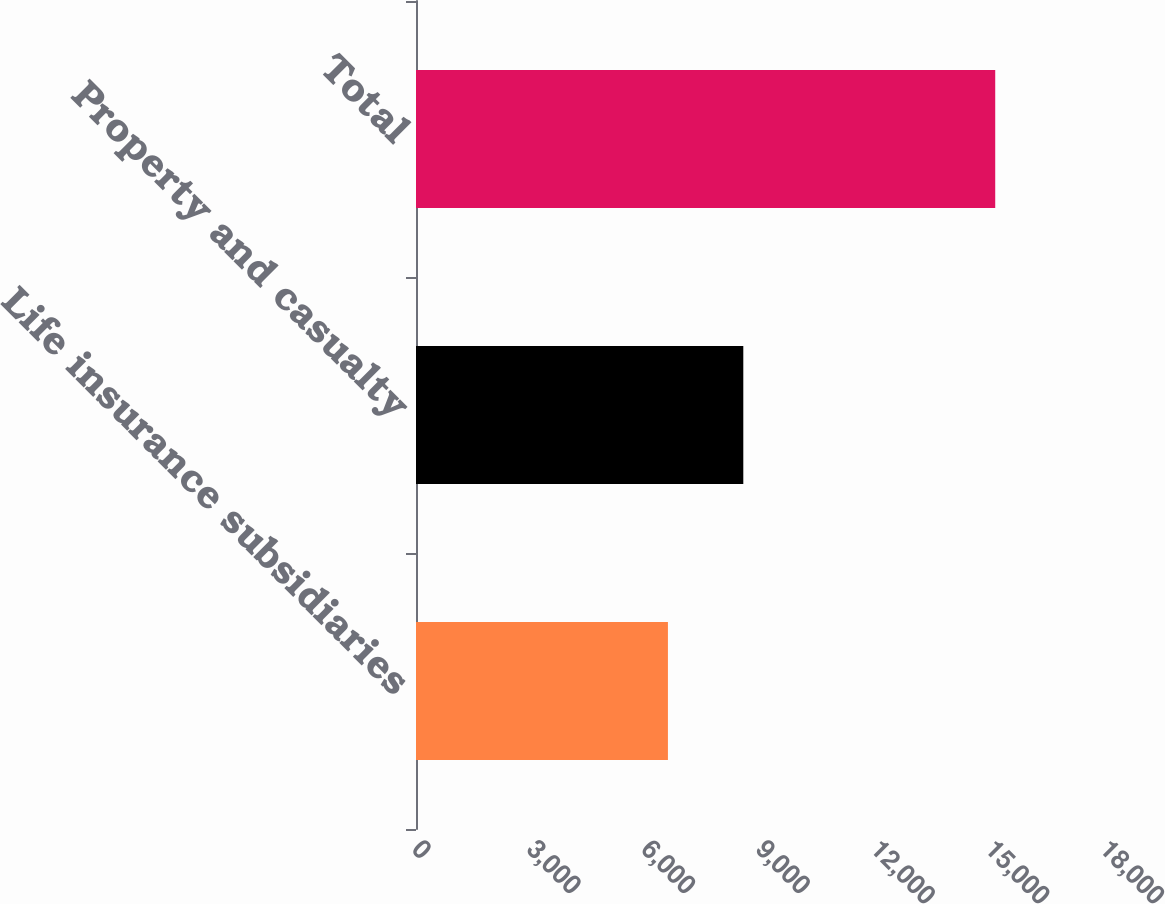Convert chart to OTSL. <chart><loc_0><loc_0><loc_500><loc_500><bar_chart><fcel>Life insurance subsidiaries<fcel>Property and casualty<fcel>Total<nl><fcel>6591<fcel>8563<fcel>15154<nl></chart> 